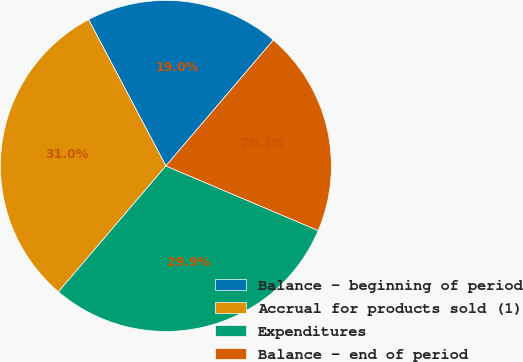Convert chart. <chart><loc_0><loc_0><loc_500><loc_500><pie_chart><fcel>Balance - beginning of period<fcel>Accrual for products sold (1)<fcel>Expenditures<fcel>Balance - end of period<nl><fcel>18.98%<fcel>31.02%<fcel>29.86%<fcel>20.14%<nl></chart> 